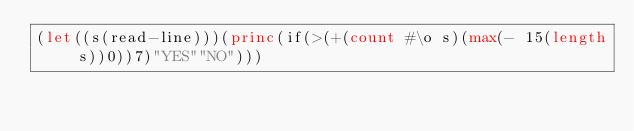Convert code to text. <code><loc_0><loc_0><loc_500><loc_500><_Lisp_>(let((s(read-line)))(princ(if(>(+(count #\o s)(max(- 15(length s))0))7)"YES""NO")))</code> 